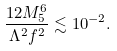<formula> <loc_0><loc_0><loc_500><loc_500>\frac { 1 2 M _ { 5 } ^ { 6 } } { \Lambda ^ { 2 } f ^ { 2 } } \lesssim 1 0 ^ { - 2 } .</formula> 